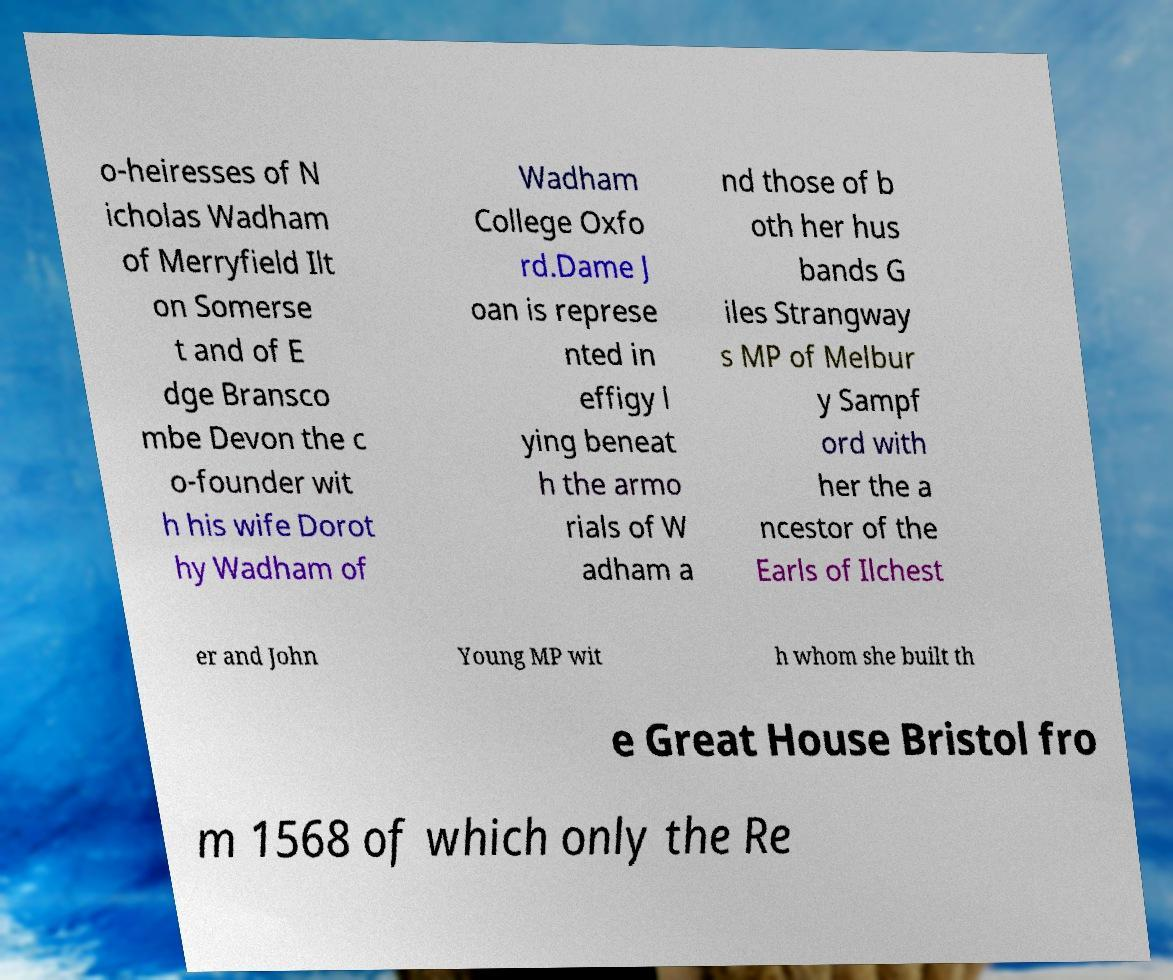Please identify and transcribe the text found in this image. o-heiresses of N icholas Wadham of Merryfield Ilt on Somerse t and of E dge Bransco mbe Devon the c o-founder wit h his wife Dorot hy Wadham of Wadham College Oxfo rd.Dame J oan is represe nted in effigy l ying beneat h the armo rials of W adham a nd those of b oth her hus bands G iles Strangway s MP of Melbur y Sampf ord with her the a ncestor of the Earls of Ilchest er and John Young MP wit h whom she built th e Great House Bristol fro m 1568 of which only the Re 